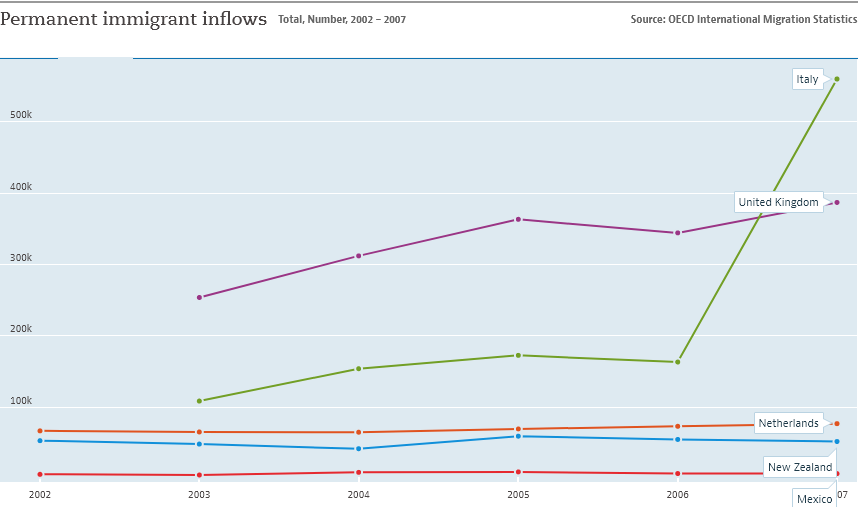Give some essential details in this illustration. There are two countries that have recorded permanent immigration flows of more than 300,000 individuals. The country represented by the green color line is Italy. 